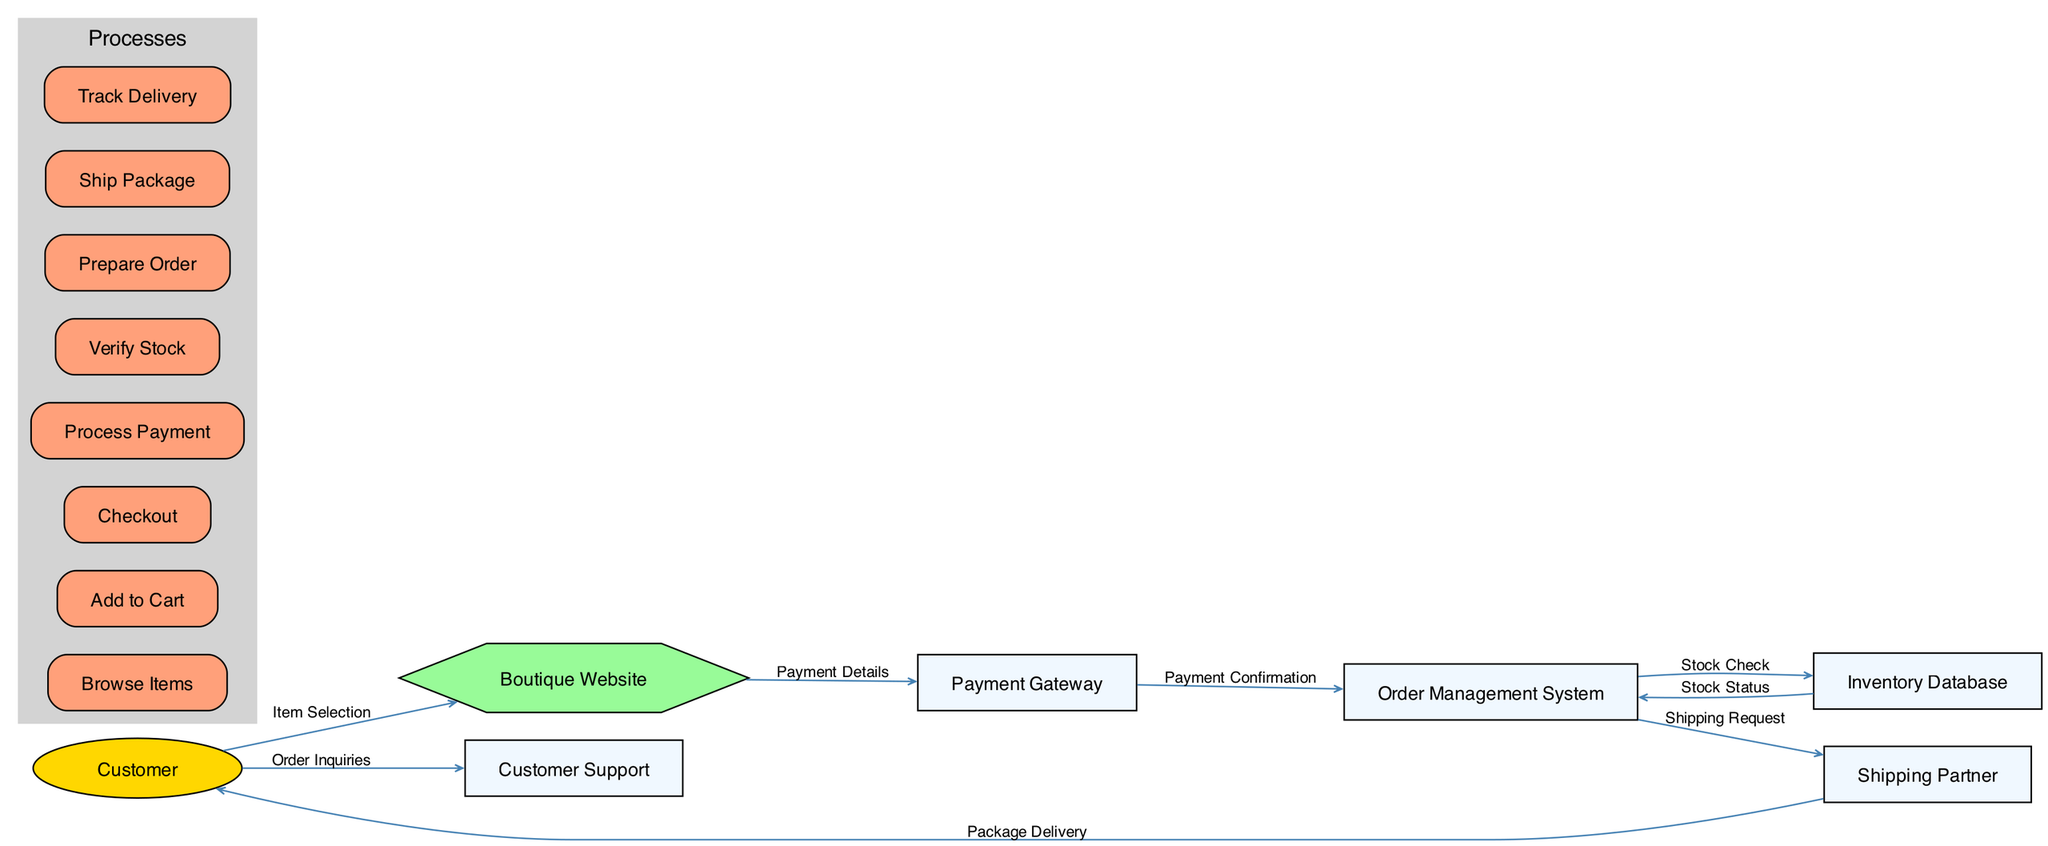What is the first action a customer takes in the order processing system? The diagram indicates that the first action taken by the customer is to select items, which is labeled as "Item Selection" directed towards the "Boutique Website."
Answer: Item Selection How many main processes are involved in the order processing system? By reviewing the "Processes" section within the diagram, I counted a total of eight distinct processes.
Answer: Eight Which entity receives the "Payment Confirmation"? Following the flow from the "Payment Gateway," the "Payment Confirmation" is sent to the "Order Management System," making it the recipient.
Answer: Order Management System What action follows "Prepare Order" in the order processing sequence? The flow can be traced from "Prepare Order" to the "Shipping Partner," indicating that this is the next step in the sequence.
Answer: Ship Package How many entities are part of the online boutique order processing system? In total, there are seven entities identified in the diagram that play a role in the order processing system.
Answer: Seven Which process is responsible for checking stock availability? Looking at the processes, "Verify Stock" is specifically labeled to check stock availability in conjunction with the "Inventory Database."
Answer: Verify Stock What type of inquiries can customers make to support? The diagram indicates that customers can make inquiries related to their orders, specifically labeled as "Order Inquiries" directed towards "Customer Support."
Answer: Order Inquiries Which entity sends the shipping request after payment is processed? The "Order Management System" is responsible for sending a "Shipping Request" to the "Shipping Partner" after payment is confirmed.
Answer: Order Management System What is the last step in the data flow of an order? The final step in the flow, indicated in the diagram, is "Package Delivery," which is where the "Shipping Partner" delivers the package to the "Customer."
Answer: Package Delivery 